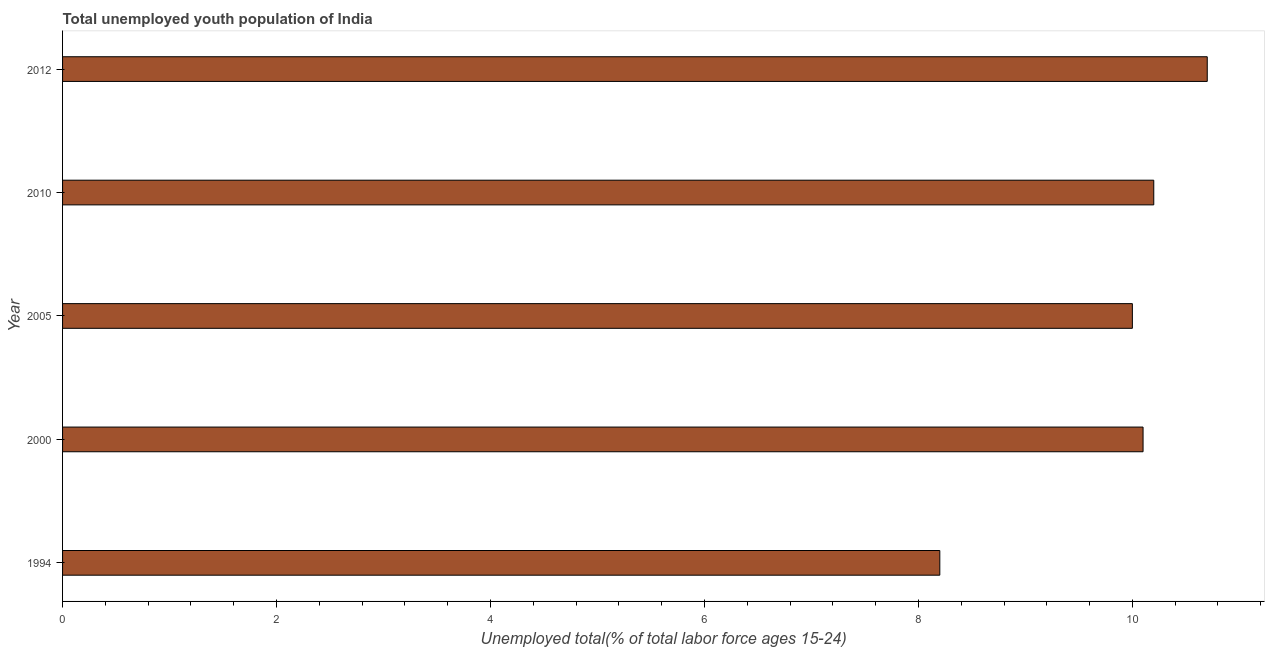Does the graph contain grids?
Make the answer very short. No. What is the title of the graph?
Provide a succinct answer. Total unemployed youth population of India. What is the label or title of the X-axis?
Provide a short and direct response. Unemployed total(% of total labor force ages 15-24). What is the label or title of the Y-axis?
Your response must be concise. Year. What is the unemployed youth in 1994?
Give a very brief answer. 8.2. Across all years, what is the maximum unemployed youth?
Your answer should be very brief. 10.7. Across all years, what is the minimum unemployed youth?
Ensure brevity in your answer.  8.2. In which year was the unemployed youth minimum?
Your answer should be compact. 1994. What is the sum of the unemployed youth?
Make the answer very short. 49.2. What is the difference between the unemployed youth in 2000 and 2005?
Your answer should be compact. 0.1. What is the average unemployed youth per year?
Your response must be concise. 9.84. What is the median unemployed youth?
Your response must be concise. 10.1. Do a majority of the years between 2000 and 2005 (inclusive) have unemployed youth greater than 1.6 %?
Keep it short and to the point. Yes. What is the ratio of the unemployed youth in 1994 to that in 2005?
Your answer should be very brief. 0.82. Is the unemployed youth in 2010 less than that in 2012?
Your answer should be very brief. Yes. Is the difference between the unemployed youth in 2000 and 2012 greater than the difference between any two years?
Offer a very short reply. No. What is the difference between the highest and the lowest unemployed youth?
Provide a short and direct response. 2.5. How many years are there in the graph?
Your answer should be compact. 5. What is the difference between two consecutive major ticks on the X-axis?
Keep it short and to the point. 2. What is the Unemployed total(% of total labor force ages 15-24) in 1994?
Your response must be concise. 8.2. What is the Unemployed total(% of total labor force ages 15-24) in 2000?
Provide a succinct answer. 10.1. What is the Unemployed total(% of total labor force ages 15-24) of 2005?
Offer a very short reply. 10. What is the Unemployed total(% of total labor force ages 15-24) of 2010?
Ensure brevity in your answer.  10.2. What is the Unemployed total(% of total labor force ages 15-24) in 2012?
Provide a short and direct response. 10.7. What is the difference between the Unemployed total(% of total labor force ages 15-24) in 2005 and 2010?
Ensure brevity in your answer.  -0.2. What is the difference between the Unemployed total(% of total labor force ages 15-24) in 2010 and 2012?
Make the answer very short. -0.5. What is the ratio of the Unemployed total(% of total labor force ages 15-24) in 1994 to that in 2000?
Offer a very short reply. 0.81. What is the ratio of the Unemployed total(% of total labor force ages 15-24) in 1994 to that in 2005?
Your response must be concise. 0.82. What is the ratio of the Unemployed total(% of total labor force ages 15-24) in 1994 to that in 2010?
Keep it short and to the point. 0.8. What is the ratio of the Unemployed total(% of total labor force ages 15-24) in 1994 to that in 2012?
Your response must be concise. 0.77. What is the ratio of the Unemployed total(% of total labor force ages 15-24) in 2000 to that in 2005?
Offer a very short reply. 1.01. What is the ratio of the Unemployed total(% of total labor force ages 15-24) in 2000 to that in 2010?
Provide a succinct answer. 0.99. What is the ratio of the Unemployed total(% of total labor force ages 15-24) in 2000 to that in 2012?
Give a very brief answer. 0.94. What is the ratio of the Unemployed total(% of total labor force ages 15-24) in 2005 to that in 2010?
Your response must be concise. 0.98. What is the ratio of the Unemployed total(% of total labor force ages 15-24) in 2005 to that in 2012?
Give a very brief answer. 0.94. What is the ratio of the Unemployed total(% of total labor force ages 15-24) in 2010 to that in 2012?
Give a very brief answer. 0.95. 